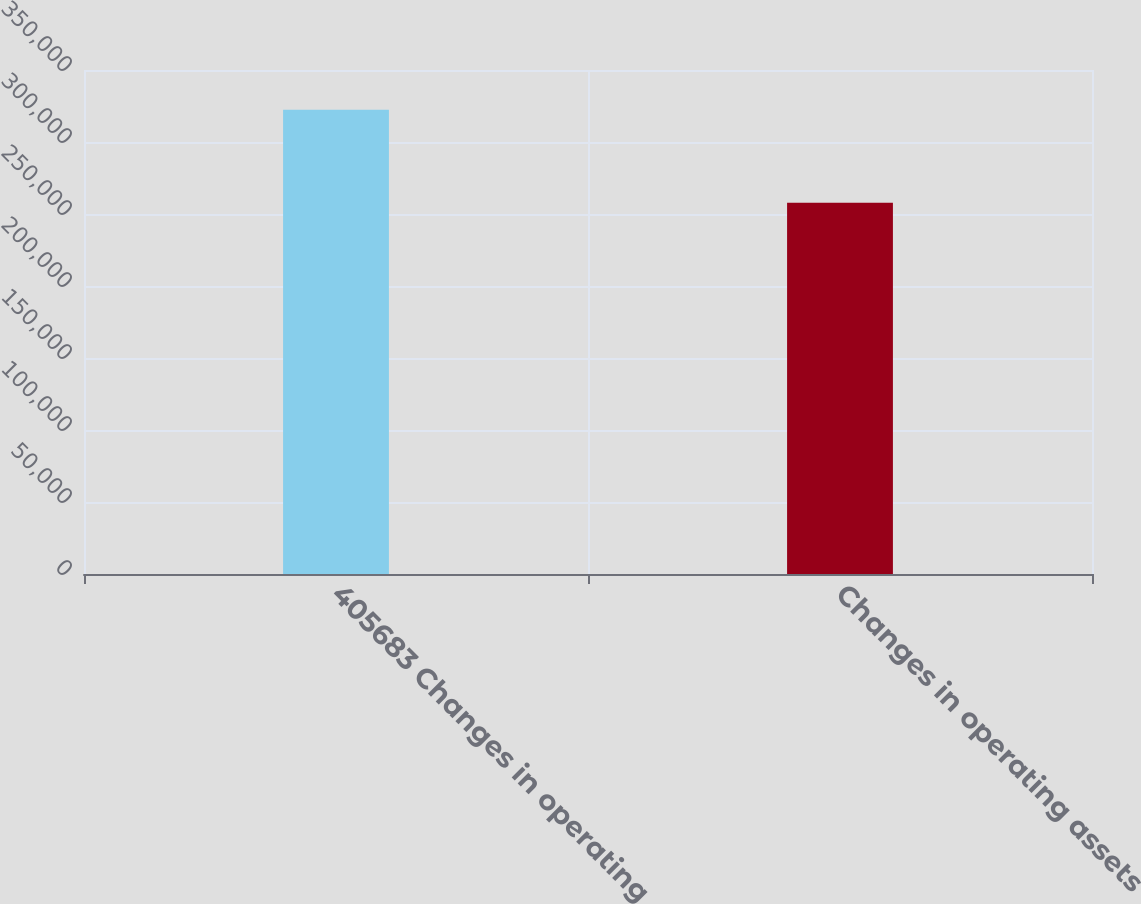Convert chart to OTSL. <chart><loc_0><loc_0><loc_500><loc_500><bar_chart><fcel>405683 Changes in operating<fcel>Changes in operating assets<nl><fcel>322388<fcel>257795<nl></chart> 